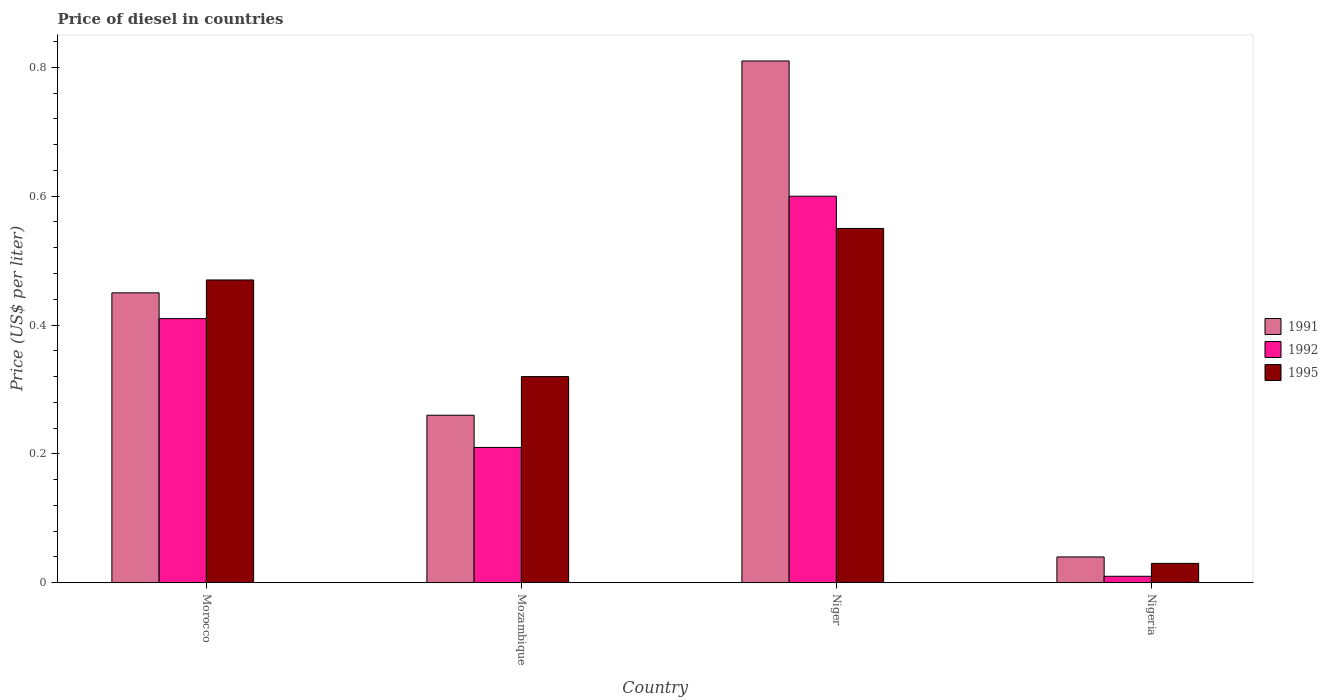How many bars are there on the 4th tick from the right?
Your answer should be compact. 3. What is the label of the 4th group of bars from the left?
Your answer should be compact. Nigeria. What is the price of diesel in 1995 in Mozambique?
Offer a very short reply. 0.32. Across all countries, what is the maximum price of diesel in 1991?
Your response must be concise. 0.81. Across all countries, what is the minimum price of diesel in 1992?
Provide a short and direct response. 0.01. In which country was the price of diesel in 1991 maximum?
Offer a very short reply. Niger. In which country was the price of diesel in 1991 minimum?
Ensure brevity in your answer.  Nigeria. What is the total price of diesel in 1991 in the graph?
Your answer should be very brief. 1.56. What is the difference between the price of diesel in 1995 in Morocco and that in Niger?
Make the answer very short. -0.08. What is the difference between the price of diesel in 1995 in Morocco and the price of diesel in 1992 in Mozambique?
Provide a succinct answer. 0.26. What is the average price of diesel in 1995 per country?
Provide a succinct answer. 0.34. What is the difference between the price of diesel of/in 1991 and price of diesel of/in 1995 in Niger?
Your answer should be compact. 0.26. In how many countries, is the price of diesel in 1991 greater than 0.32 US$?
Provide a succinct answer. 2. What is the ratio of the price of diesel in 1991 in Morocco to that in Niger?
Provide a succinct answer. 0.56. Is the difference between the price of diesel in 1991 in Morocco and Niger greater than the difference between the price of diesel in 1995 in Morocco and Niger?
Give a very brief answer. No. What is the difference between the highest and the second highest price of diesel in 1991?
Your response must be concise. 0.55. What is the difference between the highest and the lowest price of diesel in 1992?
Provide a short and direct response. 0.59. Is the sum of the price of diesel in 1995 in Morocco and Nigeria greater than the maximum price of diesel in 1992 across all countries?
Provide a short and direct response. No. What does the 1st bar from the left in Nigeria represents?
Offer a terse response. 1991. What does the 3rd bar from the right in Nigeria represents?
Make the answer very short. 1991. Is it the case that in every country, the sum of the price of diesel in 1991 and price of diesel in 1995 is greater than the price of diesel in 1992?
Your answer should be very brief. Yes. How many bars are there?
Your response must be concise. 12. How many countries are there in the graph?
Your answer should be compact. 4. How are the legend labels stacked?
Offer a very short reply. Vertical. What is the title of the graph?
Offer a terse response. Price of diesel in countries. What is the label or title of the Y-axis?
Your response must be concise. Price (US$ per liter). What is the Price (US$ per liter) in 1991 in Morocco?
Your answer should be very brief. 0.45. What is the Price (US$ per liter) of 1992 in Morocco?
Your answer should be very brief. 0.41. What is the Price (US$ per liter) of 1995 in Morocco?
Your answer should be very brief. 0.47. What is the Price (US$ per liter) in 1991 in Mozambique?
Provide a succinct answer. 0.26. What is the Price (US$ per liter) of 1992 in Mozambique?
Your answer should be very brief. 0.21. What is the Price (US$ per liter) in 1995 in Mozambique?
Give a very brief answer. 0.32. What is the Price (US$ per liter) in 1991 in Niger?
Your answer should be compact. 0.81. What is the Price (US$ per liter) of 1992 in Niger?
Keep it short and to the point. 0.6. What is the Price (US$ per liter) of 1995 in Niger?
Offer a terse response. 0.55. What is the Price (US$ per liter) of 1991 in Nigeria?
Provide a succinct answer. 0.04. What is the Price (US$ per liter) of 1995 in Nigeria?
Provide a short and direct response. 0.03. Across all countries, what is the maximum Price (US$ per liter) in 1991?
Provide a succinct answer. 0.81. Across all countries, what is the maximum Price (US$ per liter) of 1992?
Ensure brevity in your answer.  0.6. Across all countries, what is the maximum Price (US$ per liter) of 1995?
Provide a succinct answer. 0.55. What is the total Price (US$ per liter) of 1991 in the graph?
Your answer should be very brief. 1.56. What is the total Price (US$ per liter) of 1992 in the graph?
Your answer should be compact. 1.23. What is the total Price (US$ per liter) in 1995 in the graph?
Offer a very short reply. 1.37. What is the difference between the Price (US$ per liter) of 1991 in Morocco and that in Mozambique?
Give a very brief answer. 0.19. What is the difference between the Price (US$ per liter) of 1995 in Morocco and that in Mozambique?
Give a very brief answer. 0.15. What is the difference between the Price (US$ per liter) of 1991 in Morocco and that in Niger?
Offer a terse response. -0.36. What is the difference between the Price (US$ per liter) in 1992 in Morocco and that in Niger?
Give a very brief answer. -0.19. What is the difference between the Price (US$ per liter) in 1995 in Morocco and that in Niger?
Provide a short and direct response. -0.08. What is the difference between the Price (US$ per liter) of 1991 in Morocco and that in Nigeria?
Your answer should be compact. 0.41. What is the difference between the Price (US$ per liter) in 1992 in Morocco and that in Nigeria?
Ensure brevity in your answer.  0.4. What is the difference between the Price (US$ per liter) in 1995 in Morocco and that in Nigeria?
Your response must be concise. 0.44. What is the difference between the Price (US$ per liter) of 1991 in Mozambique and that in Niger?
Provide a succinct answer. -0.55. What is the difference between the Price (US$ per liter) of 1992 in Mozambique and that in Niger?
Your answer should be compact. -0.39. What is the difference between the Price (US$ per liter) of 1995 in Mozambique and that in Niger?
Your answer should be compact. -0.23. What is the difference between the Price (US$ per liter) in 1991 in Mozambique and that in Nigeria?
Provide a succinct answer. 0.22. What is the difference between the Price (US$ per liter) of 1995 in Mozambique and that in Nigeria?
Ensure brevity in your answer.  0.29. What is the difference between the Price (US$ per liter) of 1991 in Niger and that in Nigeria?
Your response must be concise. 0.77. What is the difference between the Price (US$ per liter) in 1992 in Niger and that in Nigeria?
Provide a succinct answer. 0.59. What is the difference between the Price (US$ per liter) of 1995 in Niger and that in Nigeria?
Your answer should be very brief. 0.52. What is the difference between the Price (US$ per liter) of 1991 in Morocco and the Price (US$ per liter) of 1992 in Mozambique?
Keep it short and to the point. 0.24. What is the difference between the Price (US$ per liter) in 1991 in Morocco and the Price (US$ per liter) in 1995 in Mozambique?
Your answer should be compact. 0.13. What is the difference between the Price (US$ per liter) of 1992 in Morocco and the Price (US$ per liter) of 1995 in Mozambique?
Provide a short and direct response. 0.09. What is the difference between the Price (US$ per liter) in 1991 in Morocco and the Price (US$ per liter) in 1992 in Niger?
Offer a terse response. -0.15. What is the difference between the Price (US$ per liter) in 1991 in Morocco and the Price (US$ per liter) in 1995 in Niger?
Offer a terse response. -0.1. What is the difference between the Price (US$ per liter) in 1992 in Morocco and the Price (US$ per liter) in 1995 in Niger?
Make the answer very short. -0.14. What is the difference between the Price (US$ per liter) of 1991 in Morocco and the Price (US$ per liter) of 1992 in Nigeria?
Provide a short and direct response. 0.44. What is the difference between the Price (US$ per liter) in 1991 in Morocco and the Price (US$ per liter) in 1995 in Nigeria?
Ensure brevity in your answer.  0.42. What is the difference between the Price (US$ per liter) of 1992 in Morocco and the Price (US$ per liter) of 1995 in Nigeria?
Offer a terse response. 0.38. What is the difference between the Price (US$ per liter) of 1991 in Mozambique and the Price (US$ per liter) of 1992 in Niger?
Offer a very short reply. -0.34. What is the difference between the Price (US$ per liter) in 1991 in Mozambique and the Price (US$ per liter) in 1995 in Niger?
Your response must be concise. -0.29. What is the difference between the Price (US$ per liter) in 1992 in Mozambique and the Price (US$ per liter) in 1995 in Niger?
Provide a succinct answer. -0.34. What is the difference between the Price (US$ per liter) in 1991 in Mozambique and the Price (US$ per liter) in 1992 in Nigeria?
Offer a terse response. 0.25. What is the difference between the Price (US$ per liter) of 1991 in Mozambique and the Price (US$ per liter) of 1995 in Nigeria?
Give a very brief answer. 0.23. What is the difference between the Price (US$ per liter) of 1992 in Mozambique and the Price (US$ per liter) of 1995 in Nigeria?
Your response must be concise. 0.18. What is the difference between the Price (US$ per liter) of 1991 in Niger and the Price (US$ per liter) of 1992 in Nigeria?
Provide a succinct answer. 0.8. What is the difference between the Price (US$ per liter) in 1991 in Niger and the Price (US$ per liter) in 1995 in Nigeria?
Give a very brief answer. 0.78. What is the difference between the Price (US$ per liter) of 1992 in Niger and the Price (US$ per liter) of 1995 in Nigeria?
Keep it short and to the point. 0.57. What is the average Price (US$ per liter) of 1991 per country?
Keep it short and to the point. 0.39. What is the average Price (US$ per liter) in 1992 per country?
Offer a very short reply. 0.31. What is the average Price (US$ per liter) of 1995 per country?
Offer a terse response. 0.34. What is the difference between the Price (US$ per liter) in 1991 and Price (US$ per liter) in 1992 in Morocco?
Provide a short and direct response. 0.04. What is the difference between the Price (US$ per liter) of 1991 and Price (US$ per liter) of 1995 in Morocco?
Offer a terse response. -0.02. What is the difference between the Price (US$ per liter) of 1992 and Price (US$ per liter) of 1995 in Morocco?
Your response must be concise. -0.06. What is the difference between the Price (US$ per liter) of 1991 and Price (US$ per liter) of 1995 in Mozambique?
Offer a very short reply. -0.06. What is the difference between the Price (US$ per liter) of 1992 and Price (US$ per liter) of 1995 in Mozambique?
Keep it short and to the point. -0.11. What is the difference between the Price (US$ per liter) of 1991 and Price (US$ per liter) of 1992 in Niger?
Keep it short and to the point. 0.21. What is the difference between the Price (US$ per liter) of 1991 and Price (US$ per liter) of 1995 in Niger?
Offer a terse response. 0.26. What is the difference between the Price (US$ per liter) in 1992 and Price (US$ per liter) in 1995 in Niger?
Ensure brevity in your answer.  0.05. What is the difference between the Price (US$ per liter) of 1991 and Price (US$ per liter) of 1992 in Nigeria?
Your response must be concise. 0.03. What is the difference between the Price (US$ per liter) in 1991 and Price (US$ per liter) in 1995 in Nigeria?
Provide a short and direct response. 0.01. What is the difference between the Price (US$ per liter) of 1992 and Price (US$ per liter) of 1995 in Nigeria?
Your response must be concise. -0.02. What is the ratio of the Price (US$ per liter) of 1991 in Morocco to that in Mozambique?
Provide a succinct answer. 1.73. What is the ratio of the Price (US$ per liter) of 1992 in Morocco to that in Mozambique?
Ensure brevity in your answer.  1.95. What is the ratio of the Price (US$ per liter) in 1995 in Morocco to that in Mozambique?
Provide a succinct answer. 1.47. What is the ratio of the Price (US$ per liter) in 1991 in Morocco to that in Niger?
Provide a succinct answer. 0.56. What is the ratio of the Price (US$ per liter) of 1992 in Morocco to that in Niger?
Your response must be concise. 0.68. What is the ratio of the Price (US$ per liter) in 1995 in Morocco to that in Niger?
Provide a succinct answer. 0.85. What is the ratio of the Price (US$ per liter) of 1991 in Morocco to that in Nigeria?
Your response must be concise. 11.25. What is the ratio of the Price (US$ per liter) of 1992 in Morocco to that in Nigeria?
Make the answer very short. 41. What is the ratio of the Price (US$ per liter) of 1995 in Morocco to that in Nigeria?
Your response must be concise. 15.67. What is the ratio of the Price (US$ per liter) in 1991 in Mozambique to that in Niger?
Make the answer very short. 0.32. What is the ratio of the Price (US$ per liter) of 1995 in Mozambique to that in Niger?
Provide a succinct answer. 0.58. What is the ratio of the Price (US$ per liter) in 1991 in Mozambique to that in Nigeria?
Make the answer very short. 6.5. What is the ratio of the Price (US$ per liter) of 1992 in Mozambique to that in Nigeria?
Ensure brevity in your answer.  21. What is the ratio of the Price (US$ per liter) in 1995 in Mozambique to that in Nigeria?
Your answer should be very brief. 10.67. What is the ratio of the Price (US$ per liter) in 1991 in Niger to that in Nigeria?
Give a very brief answer. 20.25. What is the ratio of the Price (US$ per liter) of 1995 in Niger to that in Nigeria?
Keep it short and to the point. 18.33. What is the difference between the highest and the second highest Price (US$ per liter) of 1991?
Give a very brief answer. 0.36. What is the difference between the highest and the second highest Price (US$ per liter) in 1992?
Your answer should be very brief. 0.19. What is the difference between the highest and the lowest Price (US$ per liter) in 1991?
Ensure brevity in your answer.  0.77. What is the difference between the highest and the lowest Price (US$ per liter) of 1992?
Give a very brief answer. 0.59. What is the difference between the highest and the lowest Price (US$ per liter) in 1995?
Give a very brief answer. 0.52. 